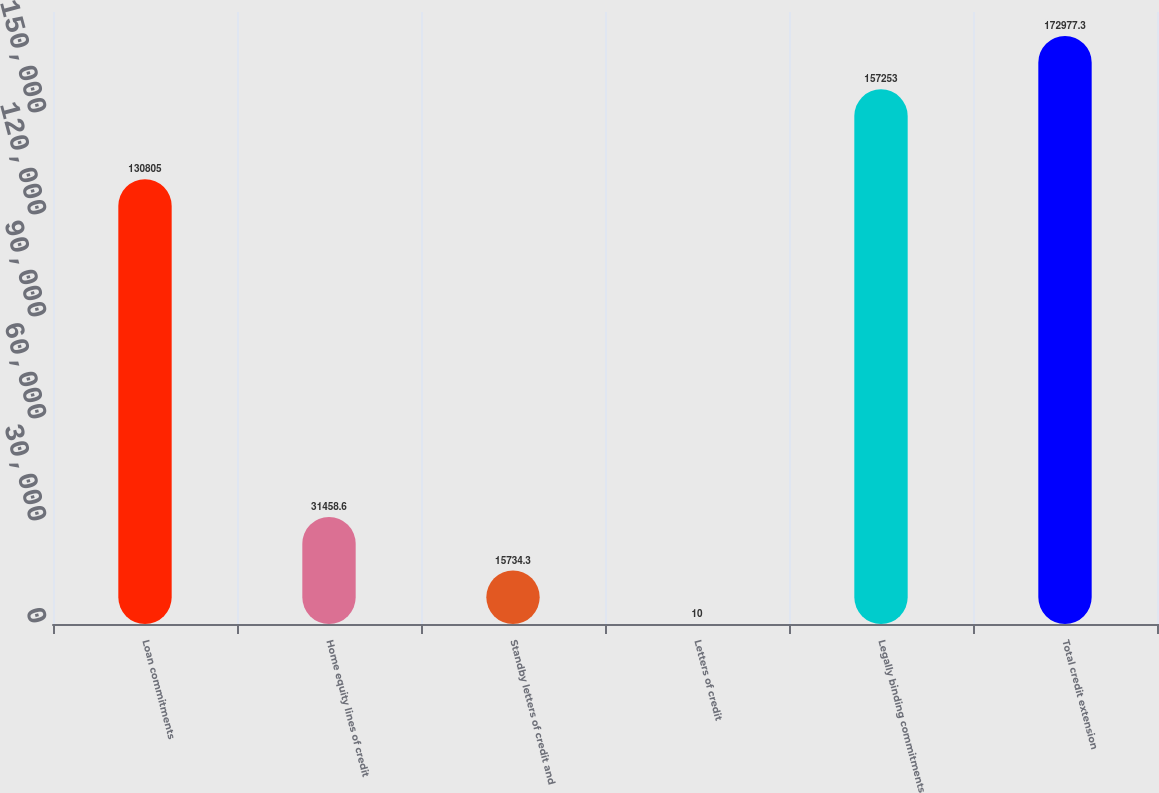<chart> <loc_0><loc_0><loc_500><loc_500><bar_chart><fcel>Loan commitments<fcel>Home equity lines of credit<fcel>Standby letters of credit and<fcel>Letters of credit<fcel>Legally binding commitments<fcel>Total credit extension<nl><fcel>130805<fcel>31458.6<fcel>15734.3<fcel>10<fcel>157253<fcel>172977<nl></chart> 